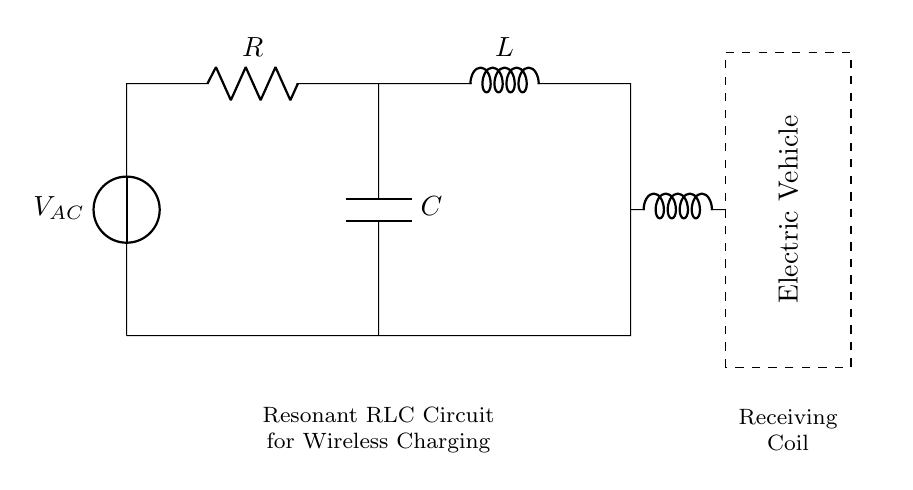What is the voltage source in this circuit? The voltage source is represented by a symbol labeled as V AC, which indicates the presence of an alternating current voltage source in the circuit.
Answer: V AC What does the rectangle represent in this diagram? The dashed rectangle around the value indicates the space reserved for the electric vehicle receiving the energy. This identifies where the wireless charging will take place.
Answer: Electric Vehicle What type of circuit is illustrated in this diagram? The components arranged denote a resonant RLC circuit used for wireless charging, characterized by the presence of a resistor, inductor, and capacitor.
Answer: Resonant RLC Circuit What is the role of the inductor in this circuit? The inductor assists in energy storage and transfers energy to the coil of the electric vehicle since the circuit is designed for wireless energy transfer.
Answer: Energy storage How are the resistor, inductor, and capacitor connected? The resistor is connected in series with the inductor, while the capacitor is connected in parallel to the resistor, forming a specific configuration critical for the circuit's functionality.
Answer: Resistor in series with inductor, capacitor in parallel What can be inferred about the charging design from the circuit layout? The layout implies that the energy transfer relies on resonance between the inductor and capacitor, making it efficient for wireless power transfer to electric vehicles parked above the charging unit.
Answer: Resonance design for efficiency 